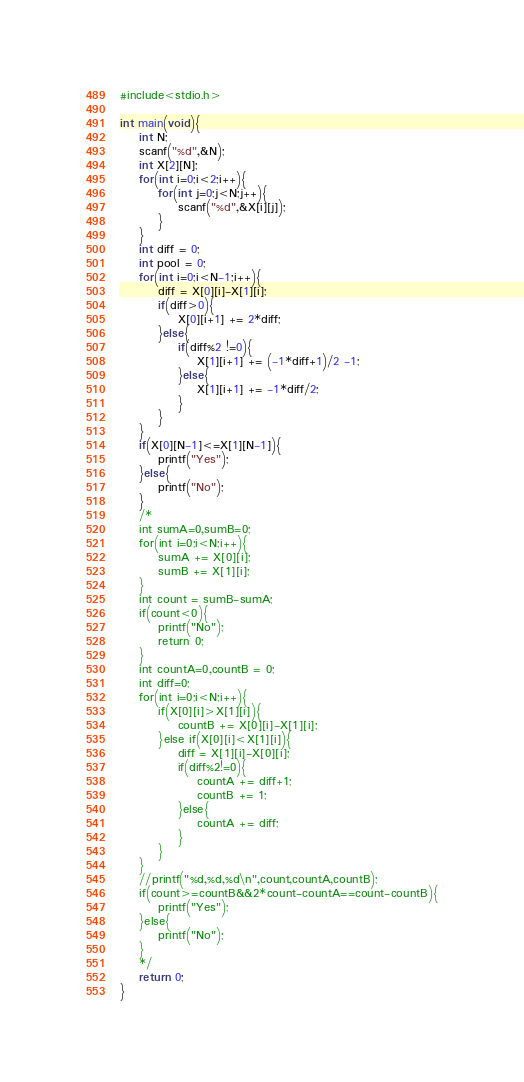Convert code to text. <code><loc_0><loc_0><loc_500><loc_500><_C_>#include<stdio.h>

int main(void){
    int N;
    scanf("%d",&N);
    int X[2][N];
    for(int i=0;i<2;i++){
        for(int j=0;j<N;j++){
            scanf("%d",&X[i][j]);
        }
    }
    int diff = 0;
    int pool = 0;
    for(int i=0;i<N-1;i++){
        diff = X[0][i]-X[1][i];
        if(diff>0){
            X[0][i+1] += 2*diff;
        }else{
            if(diff%2 !=0){
                X[1][i+1] += (-1*diff+1)/2 -1;
            }else{
                X[1][i+1] += -1*diff/2;
            }
        }
    }
    if(X[0][N-1]<=X[1][N-1]){
        printf("Yes");
    }else{
        printf("No");
    }
    /*
    int sumA=0,sumB=0;
    for(int i=0;i<N;i++){
        sumA += X[0][i];
        sumB += X[1][i];
    }
    int count = sumB-sumA;
    if(count<0){
        printf("No");
        return 0;
    }
    int countA=0,countB = 0;
    int diff=0;
    for(int i=0;i<N;i++){
        if(X[0][i]>X[1][i]){
            countB += X[0][i]-X[1][i];
        }else if(X[0][i]<X[1][i]){
            diff = X[1][i]-X[0][i];
            if(diff%2!=0){
                countA += diff+1;
                countB += 1;
            }else{
                countA += diff;
            }
        }
    }
    //printf("%d,%d,%d\n",count,countA,countB);
    if(count>=countB&&2*count-countA==count-countB){
        printf("Yes");
    }else{
        printf("No");
    }
    */
    return 0;
}</code> 